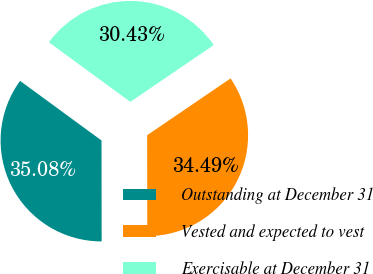Convert chart. <chart><loc_0><loc_0><loc_500><loc_500><pie_chart><fcel>Outstanding at December 31<fcel>Vested and expected to vest<fcel>Exercisable at December 31<nl><fcel>35.08%<fcel>34.49%<fcel>30.43%<nl></chart> 